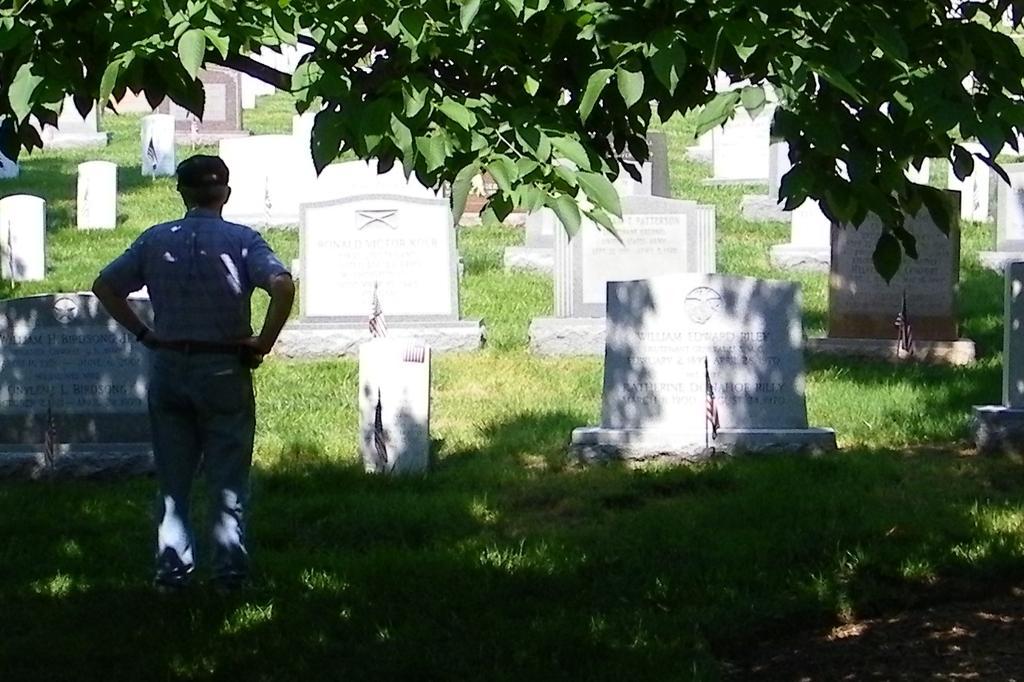Please provide a concise description of this image. In this picture I can observe graveyard. On the left side I can observe a person standing on the ground. There is some grass on the ground. In the top of the picture I can observe a tree. 